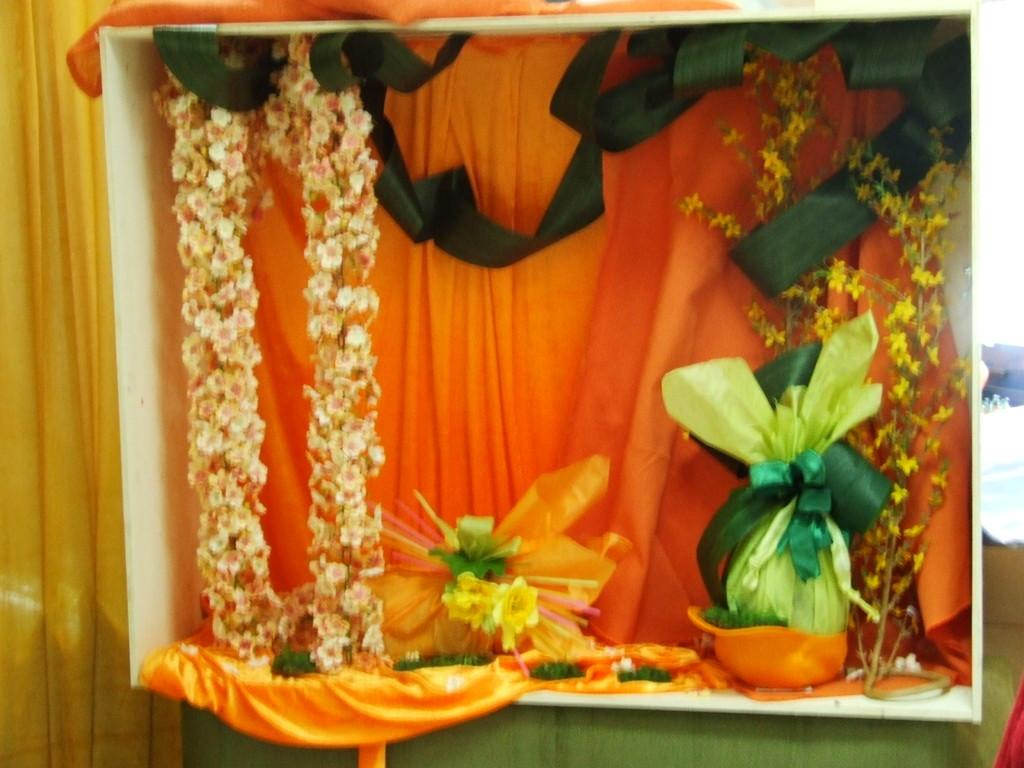What type of living organisms can be seen in the image? There are flowers in the image. What else can be seen in the image besides the flowers? There are clothes and a ribbon visible in the image. Are there any decorative elements in the image? Yes, there are decorative objects in the image. What type of wool can be seen in the image? There is no wool present in the image. What sounds can be heard coming from the decorative objects in the image? The image is static, and there is no sound associated with it. 